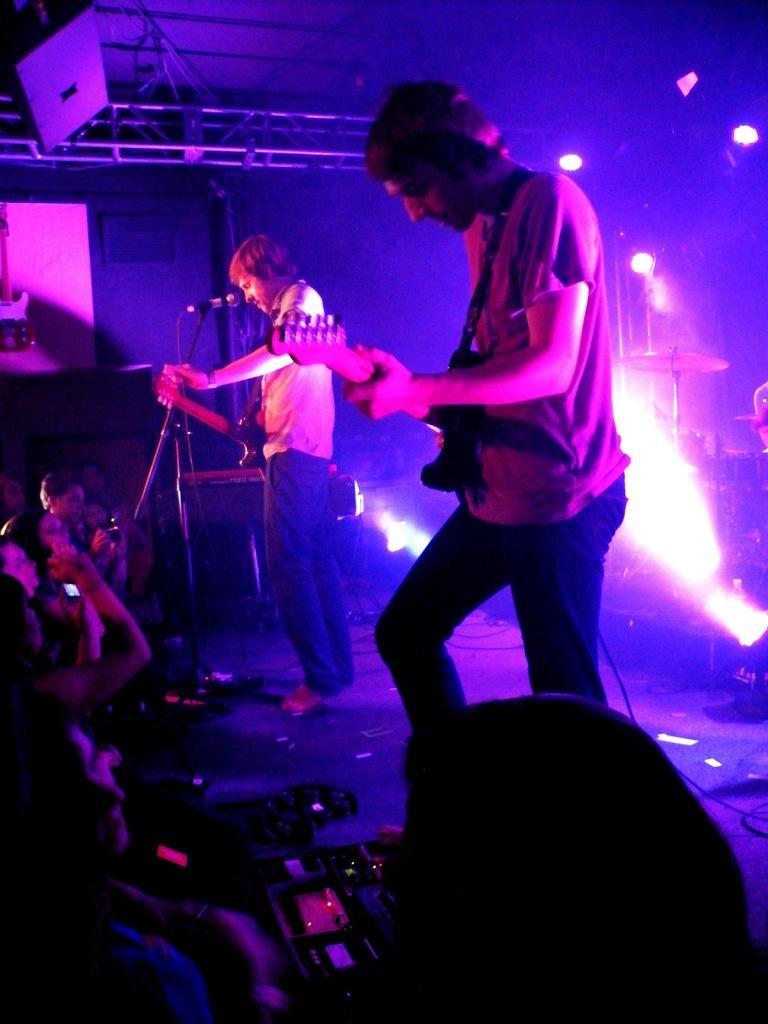In one or two sentences, can you explain what this image depicts? These two persons are standing and playing a guitar. In-front of this person there is a mic. These are musical instruments. On top there are focusing lights. These are audience. 